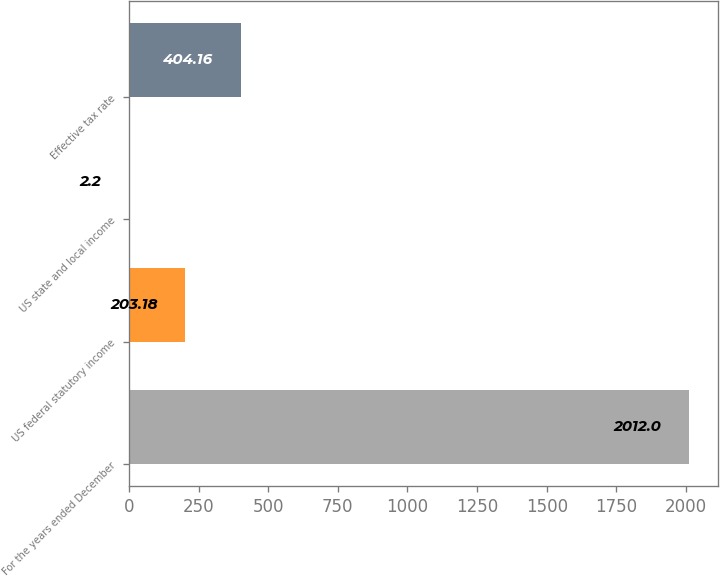Convert chart to OTSL. <chart><loc_0><loc_0><loc_500><loc_500><bar_chart><fcel>For the years ended December<fcel>US federal statutory income<fcel>US state and local income<fcel>Effective tax rate<nl><fcel>2012<fcel>203.18<fcel>2.2<fcel>404.16<nl></chart> 